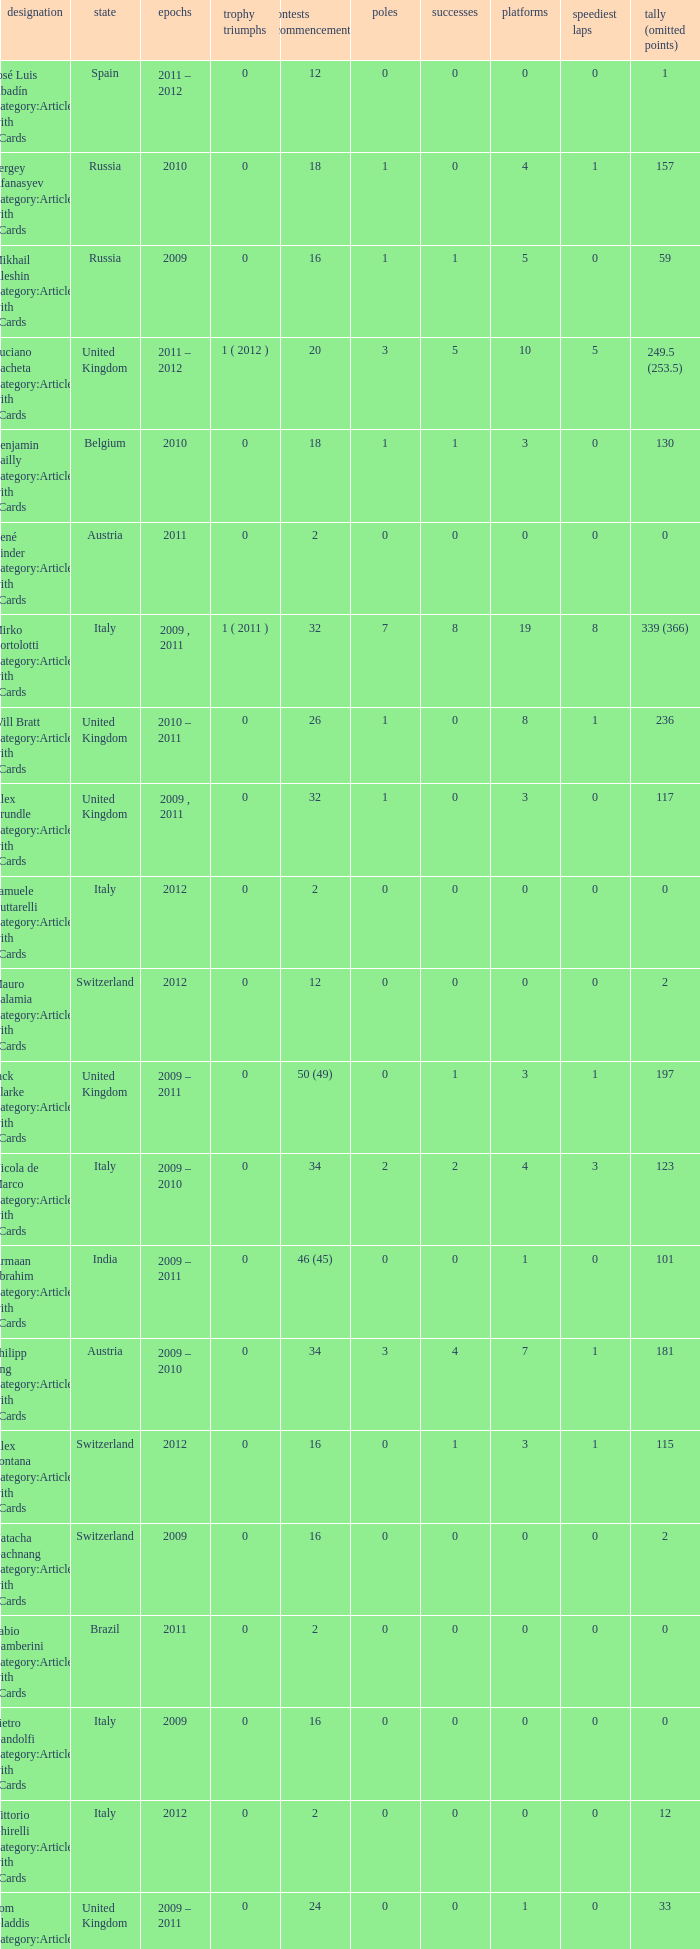What was the least amount of wins? 0.0. 